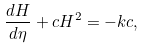<formula> <loc_0><loc_0><loc_500><loc_500>\frac { d H } { d \eta } + c H ^ { 2 } = - k c ,</formula> 